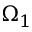<formula> <loc_0><loc_0><loc_500><loc_500>\Omega _ { 1 }</formula> 